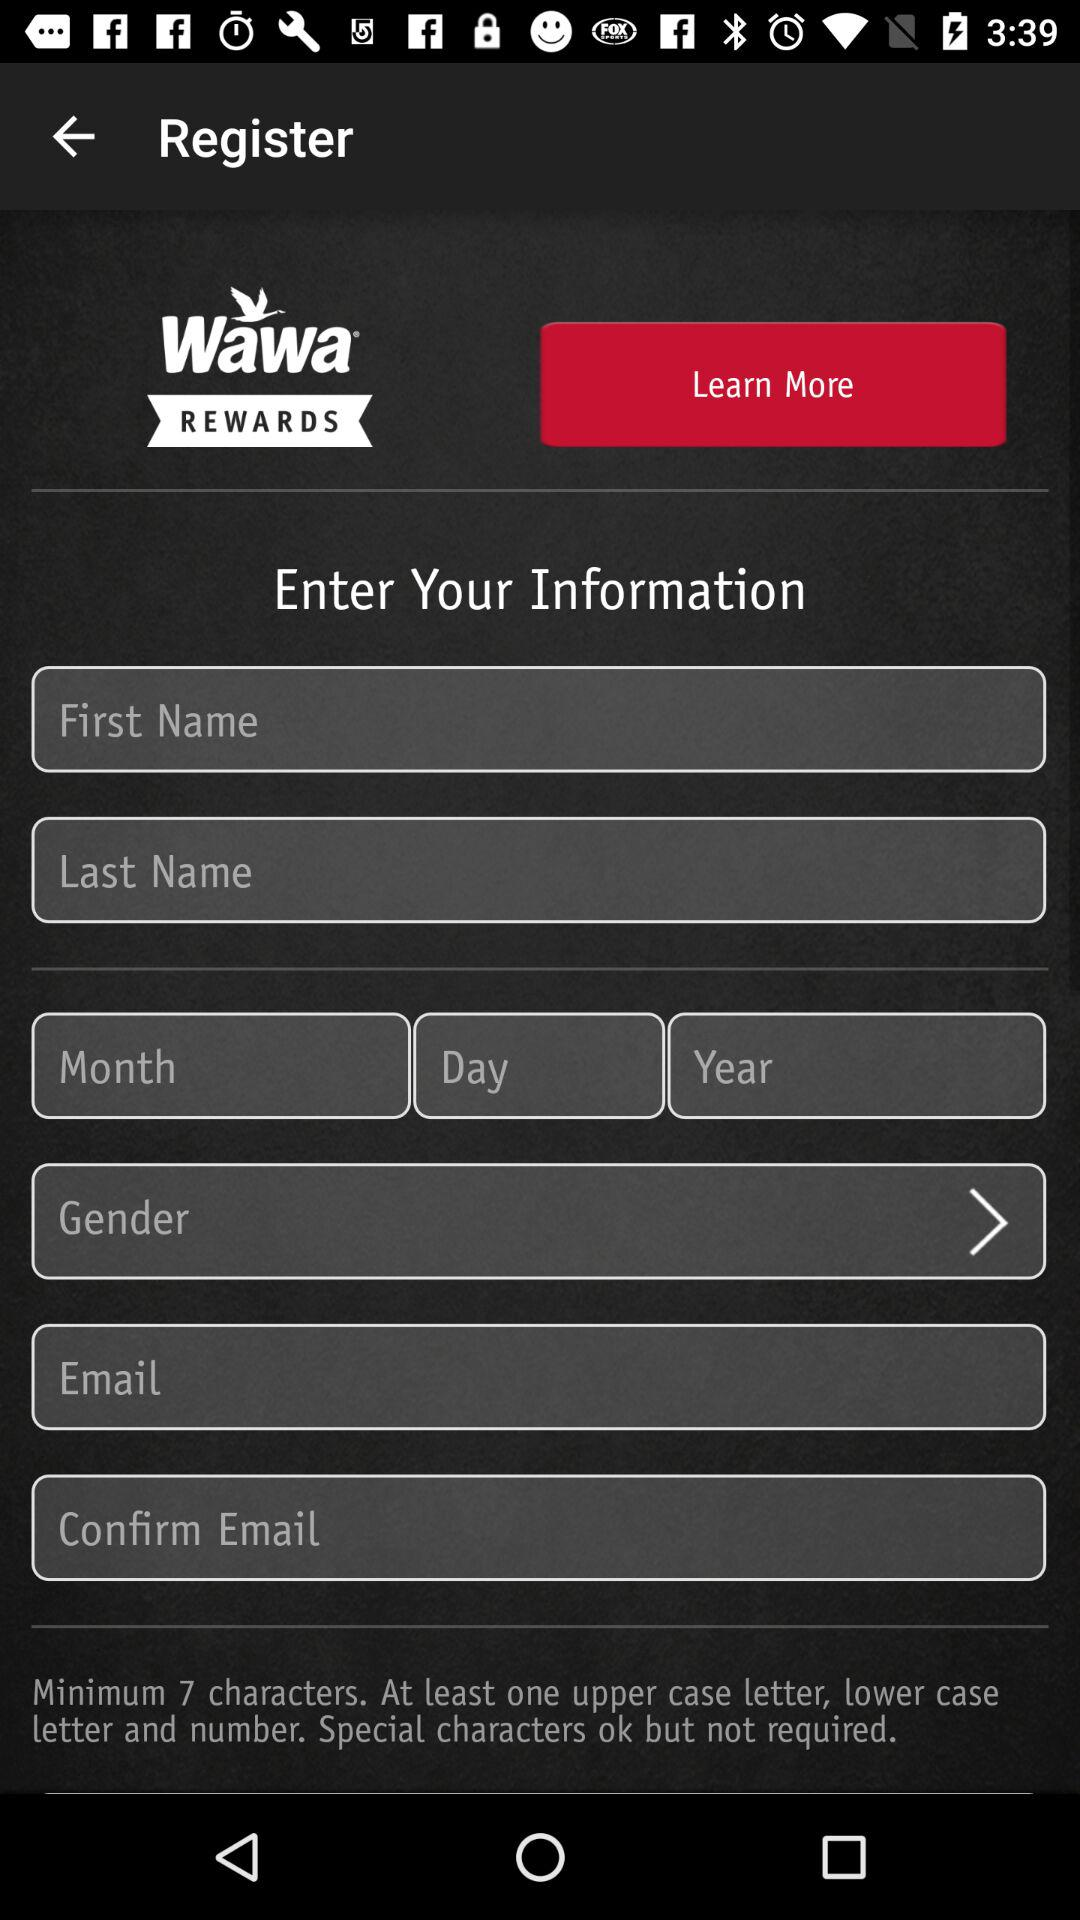How many text inputs are there for the user to enter their information?
Answer the question using a single word or phrase. 7 